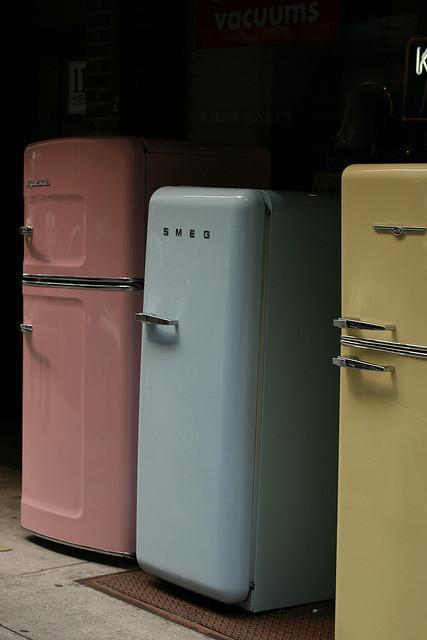How many refrigerators are visible?
Give a very brief answer. 3. How many dogs is this?
Give a very brief answer. 0. 